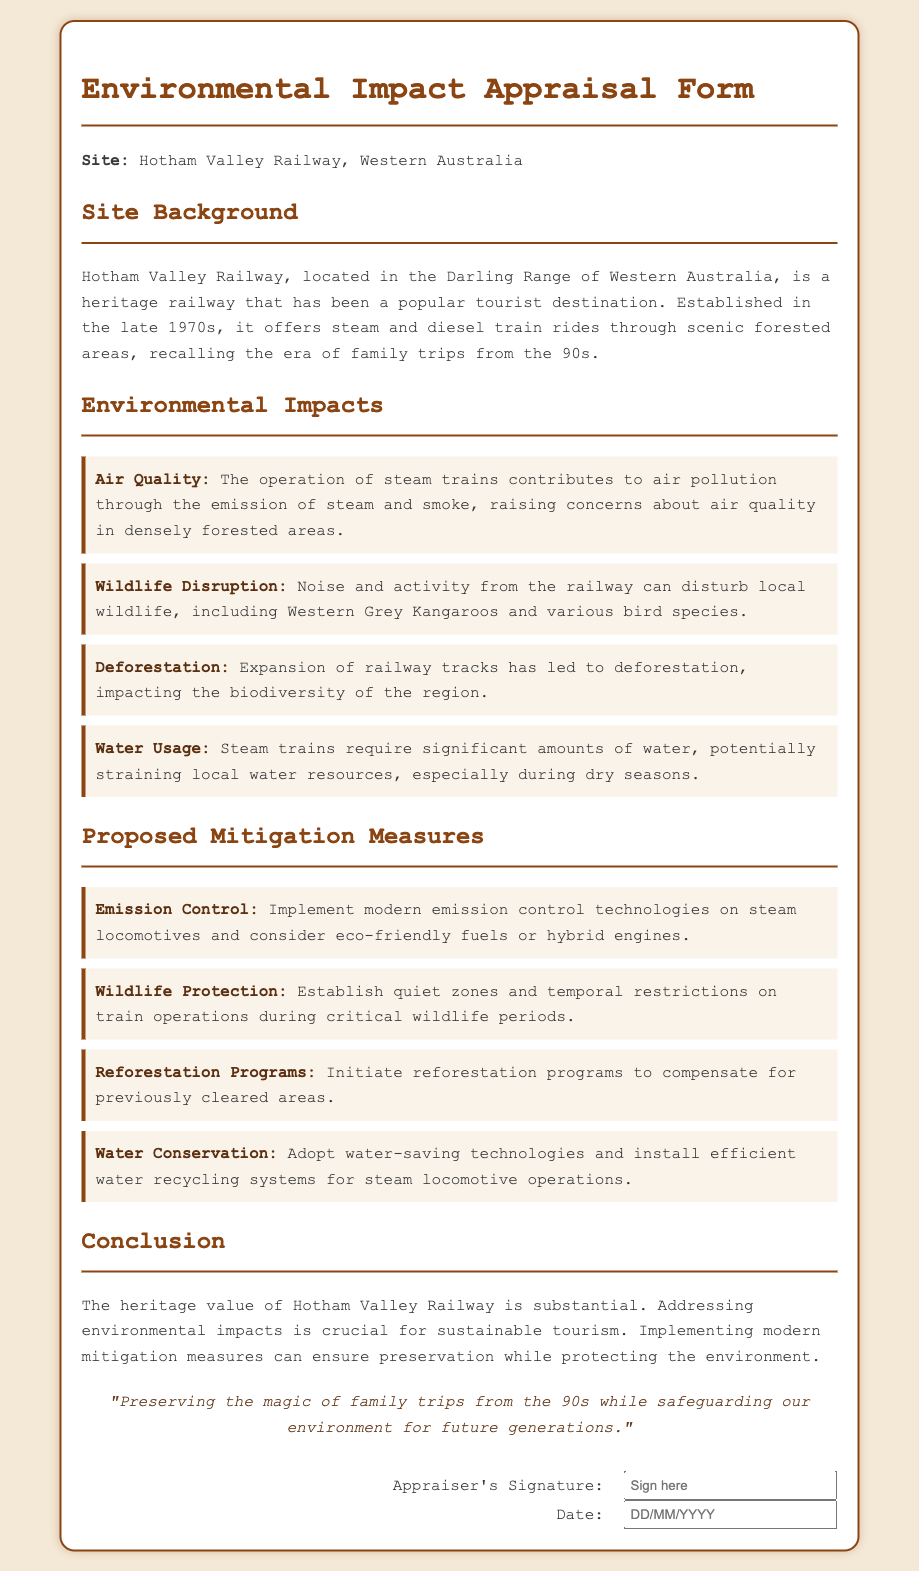What is the site covered by the appraisal form? The document specifies that the appraisal form is focused on Hotham Valley Railway in Western Australia.
Answer: Hotham Valley Railway, Western Australia When was Hotham Valley Railway established? The document indicates that it was established in the late 1970s.
Answer: late 1970s What type of trains are operated at Hotham Valley Railway? The document mentions that it offers steam and diesel train rides.
Answer: steam and diesel Name one species mentioned that is affected by noise from the railway. The document states that noise and activity from the railway can disturb Western Grey Kangaroos among other wildlife.
Answer: Western Grey Kangaroos What is one proposed measure to protect wildlife? The document lists establishing quiet zones and temporal restrictions on train operations during critical wildlife periods as one of the measures.
Answer: Establish quiet zones How does the operation of steam trains affect air quality? The document explains that the operation of steam trains contributes to air pollution through the emission of steam and smoke.
Answer: air pollution What is one environmental impact related to water usage mentioned in the document? The document states that steam trains require significant amounts of water, straining local resources, especially during dry seasons.
Answer: straining local resources What is the final note in the document suggesting about preserving the railway? The note emphasizes the importance of preserving the magic of family trips while safeguarding the environment for future generations.
Answer: preserving the magic of family trips What technological improvement is suggested for steam locomotives? The document proposes implementing modern emission control technologies on steam locomotives.
Answer: modern emission control technologies 